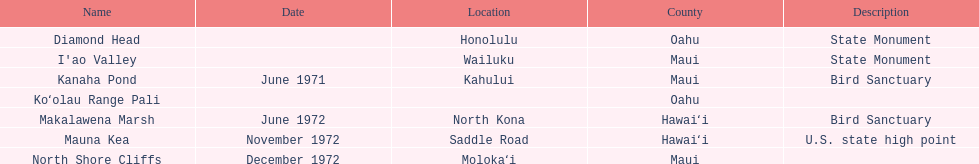Parse the full table. {'header': ['Name', 'Date', 'Location', 'County', 'Description'], 'rows': [['Diamond Head', '', 'Honolulu', 'Oahu', 'State Monument'], ["I'ao Valley", '', 'Wailuku', 'Maui', 'State Monument'], ['Kanaha Pond', 'June 1971', 'Kahului', 'Maui', 'Bird Sanctuary'], ['Koʻolau Range Pali', '', '', 'Oahu', ''], ['Makalawena Marsh', 'June 1972', 'North Kona', 'Hawaiʻi', 'Bird Sanctuary'], ['Mauna Kea', 'November 1972', 'Saddle Road', 'Hawaiʻi', 'U.S. state high point'], ['North Shore Cliffs', 'December 1972', 'Molokaʻi', 'Maui', '']]} How many names do not have a description? 2. 